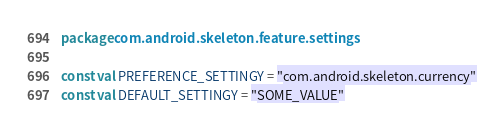Convert code to text. <code><loc_0><loc_0><loc_500><loc_500><_Kotlin_>package com.android.skeleton.feature.settings

const val PREFERENCE_SETTINGY = "com.android.skeleton.currency"
const val DEFAULT_SETTINGY = "SOME_VALUE"</code> 